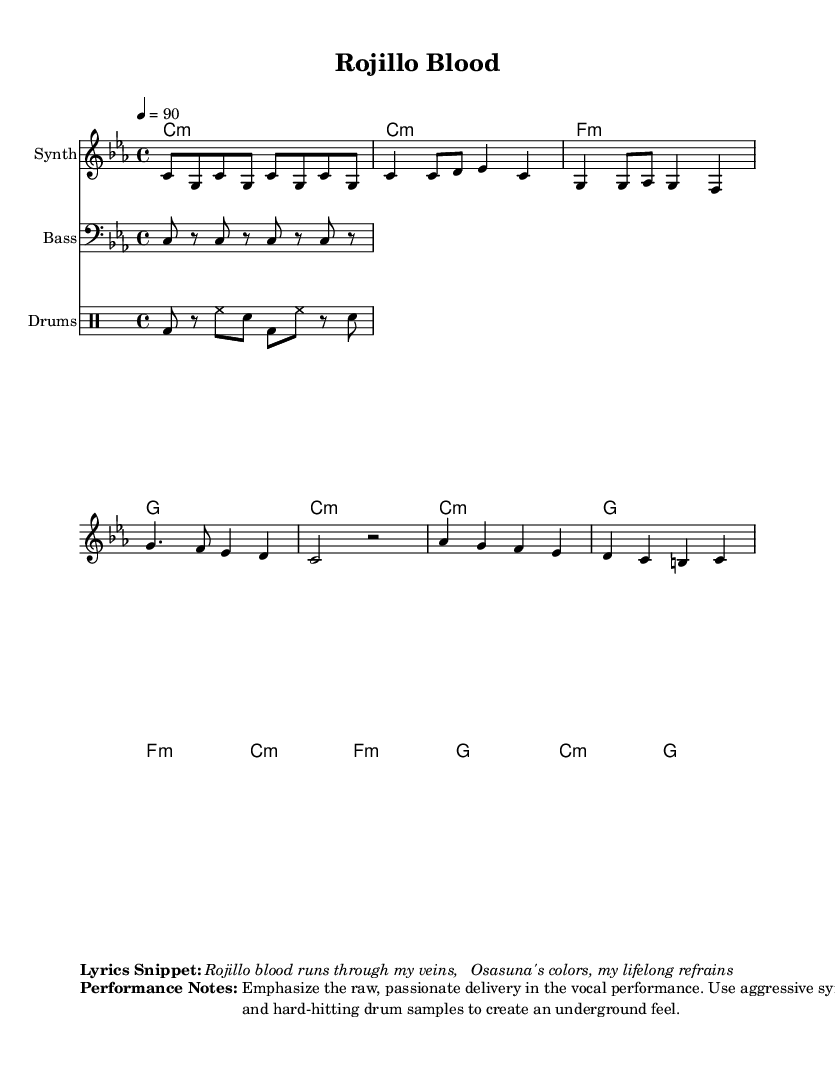What is the key signature of this music? The key signature is C minor, which contains three flats (B flat, E flat, and A flat). This is indicated at the beginning of the score.
Answer: C minor What is the time signature of this piece? The time signature is 4/4, meaning there are four beats in each measure and the quarter note receives one beat. This can be found at the start of the score.
Answer: 4/4 What is the tempo marking in this music? The tempo marking is indicated at the beginning as "4 = 90," which specifies that the quarter note should be played at a speed of 90 beats per minute.
Answer: 90 How many measures are in the verse section? The verse section includes eight measures, as evidenced by counting the measures where vocal lines are written and noting the rhythmic structure that fits within the overall layout.
Answer: 8 What type of musical instrument is featured for the melody? The melody is played on a Synth, as labeled in the score. This indicates the type of instrument that is expected to interpret the melody line provided.
Answer: Synth Which section follows the chorus in the structure of this piece? The section that follows the chorus is the Bridge, as indicated in the score by the thematic layout and the corresponding rhythmic changes present.
Answer: Bridge 